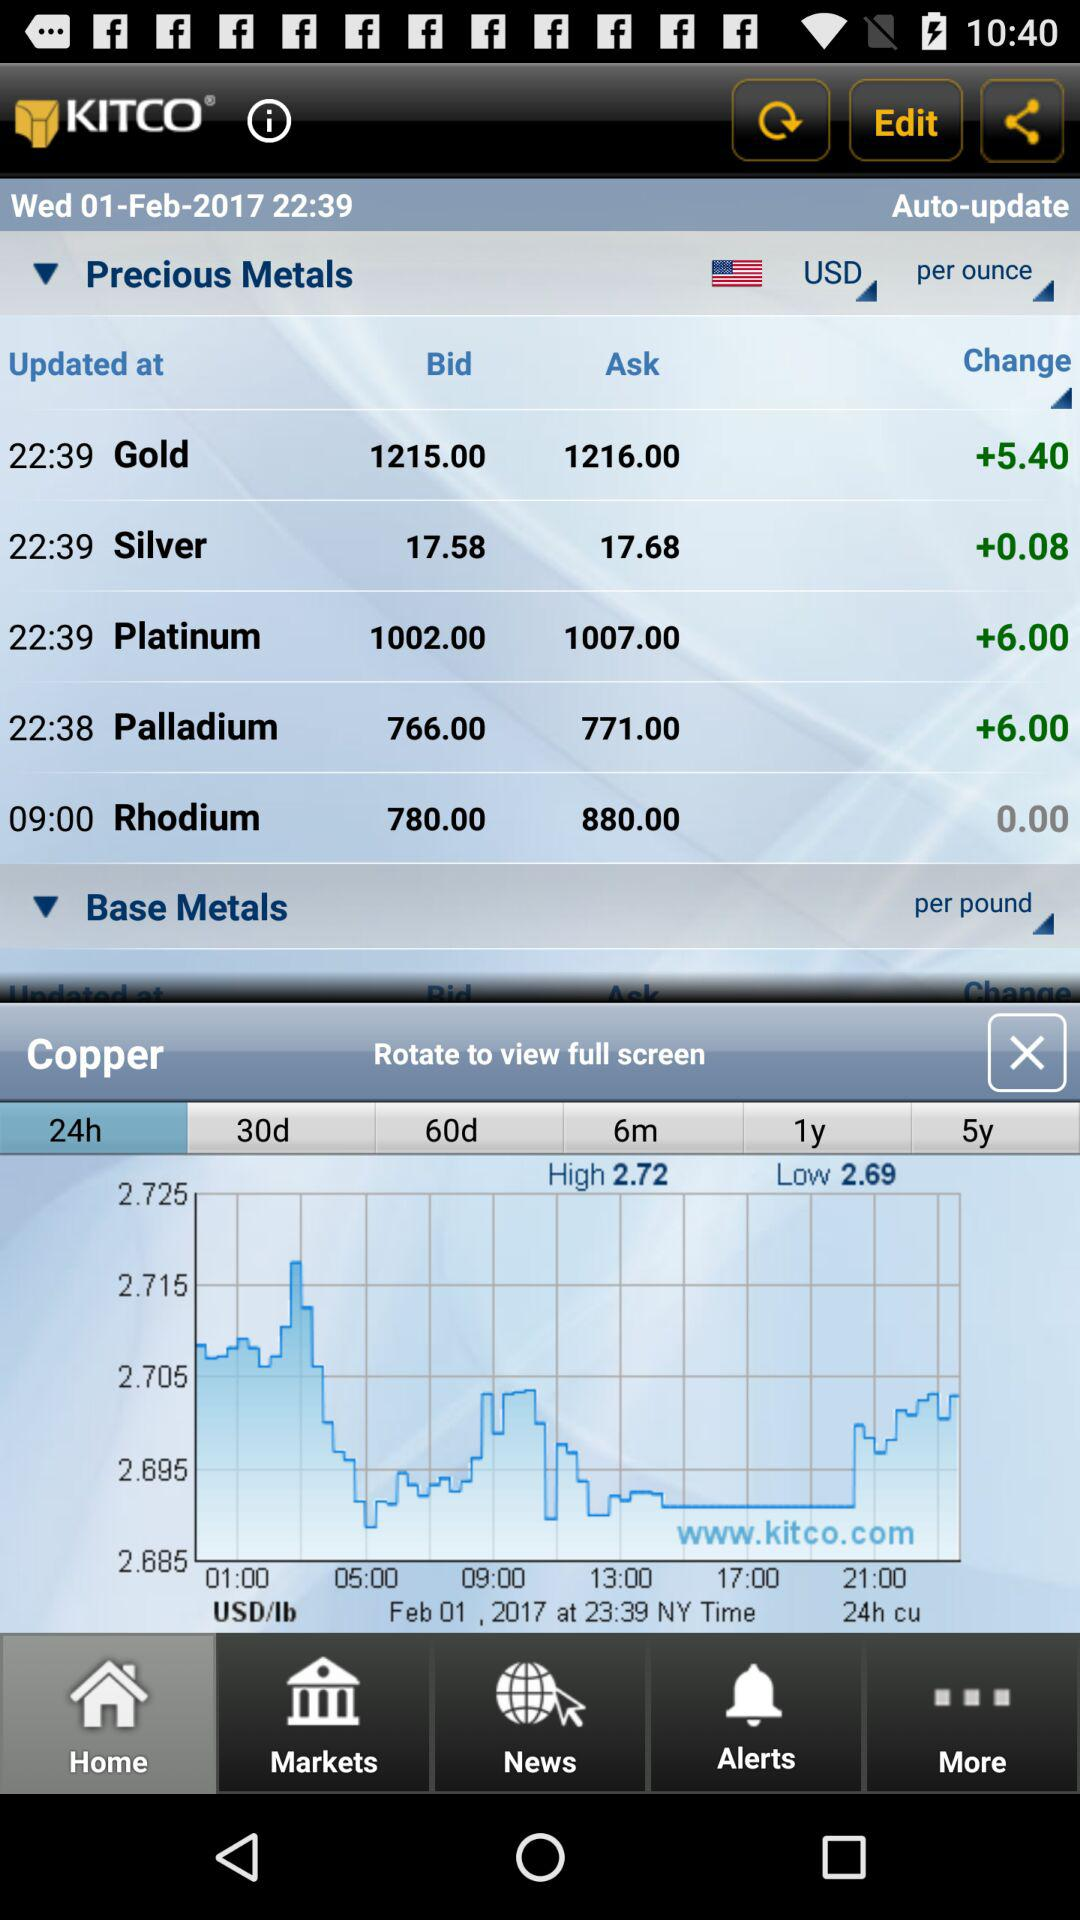What is the name of the application? The application name is "KITCO". 